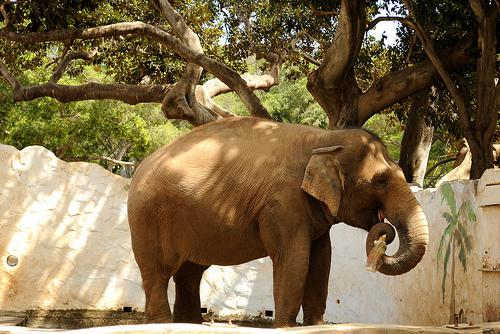Question: what is the elephant doing?
Choices:
A. Drinking water.
B. Eating.
C. Holding something in its trunk.
D. Cooling off in the water.
Answer with the letter. Answer: C Question: who is riding the elephant?
Choices:
A. No one.
B. A monkey.
C. An elephant trainer.
D. A bird.
Answer with the letter. Answer: A Question: what kind of tree in the lower right hand corner?
Choices:
A. Maple Tree.
B. Palm.
C. Dogwood Tree.
D. Lemon Tree.
Answer with the letter. Answer: B Question: what shape is the top of the wall?
Choices:
A. Irregular.
B. Rectangle.
C. Square.
D. Round.
Answer with the letter. Answer: A 